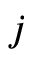<formula> <loc_0><loc_0><loc_500><loc_500>j</formula> 